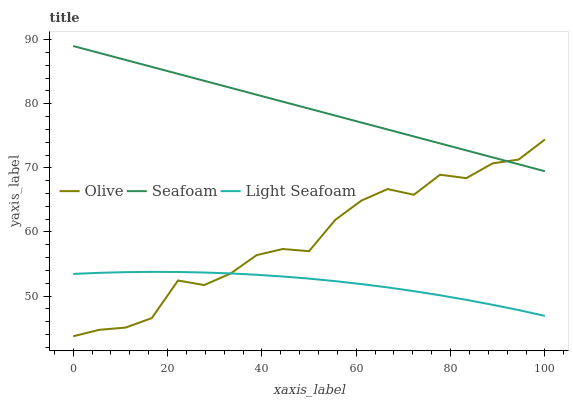Does Light Seafoam have the minimum area under the curve?
Answer yes or no. Yes. Does Seafoam have the maximum area under the curve?
Answer yes or no. Yes. Does Seafoam have the minimum area under the curve?
Answer yes or no. No. Does Light Seafoam have the maximum area under the curve?
Answer yes or no. No. Is Seafoam the smoothest?
Answer yes or no. Yes. Is Olive the roughest?
Answer yes or no. Yes. Is Light Seafoam the smoothest?
Answer yes or no. No. Is Light Seafoam the roughest?
Answer yes or no. No. Does Olive have the lowest value?
Answer yes or no. Yes. Does Light Seafoam have the lowest value?
Answer yes or no. No. Does Seafoam have the highest value?
Answer yes or no. Yes. Does Light Seafoam have the highest value?
Answer yes or no. No. Is Light Seafoam less than Seafoam?
Answer yes or no. Yes. Is Seafoam greater than Light Seafoam?
Answer yes or no. Yes. Does Light Seafoam intersect Olive?
Answer yes or no. Yes. Is Light Seafoam less than Olive?
Answer yes or no. No. Is Light Seafoam greater than Olive?
Answer yes or no. No. Does Light Seafoam intersect Seafoam?
Answer yes or no. No. 